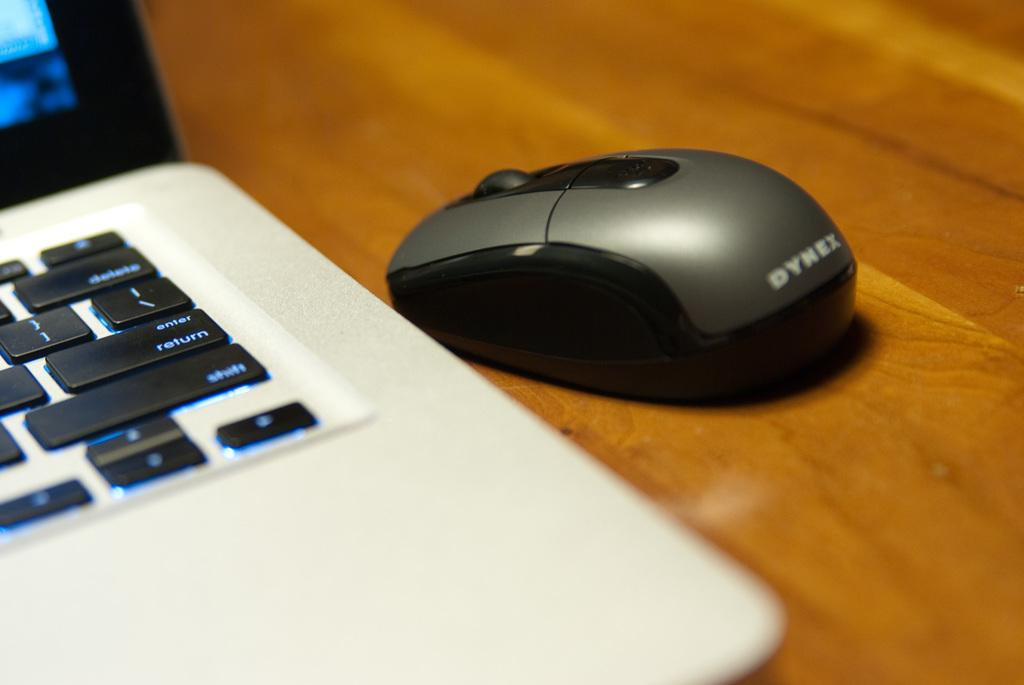<image>
Write a terse but informative summary of the picture. A black mouse next to a laptop, the mouse was made by Dynex. 